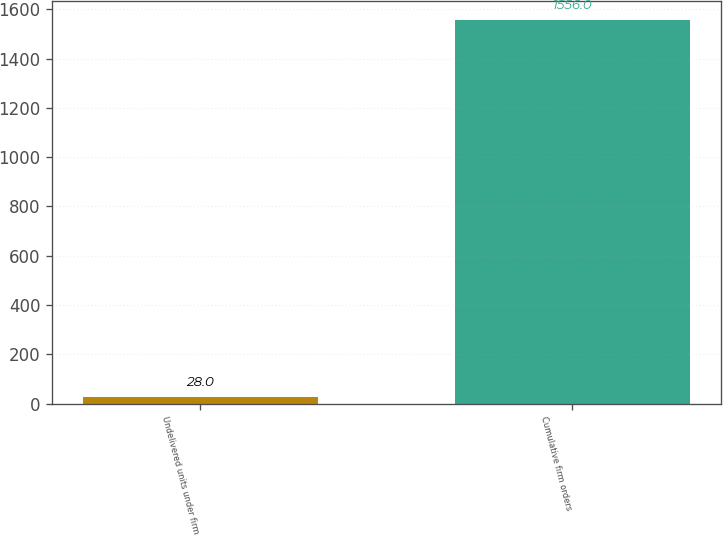<chart> <loc_0><loc_0><loc_500><loc_500><bar_chart><fcel>Undelivered units under firm<fcel>Cumulative firm orders<nl><fcel>28<fcel>1556<nl></chart> 